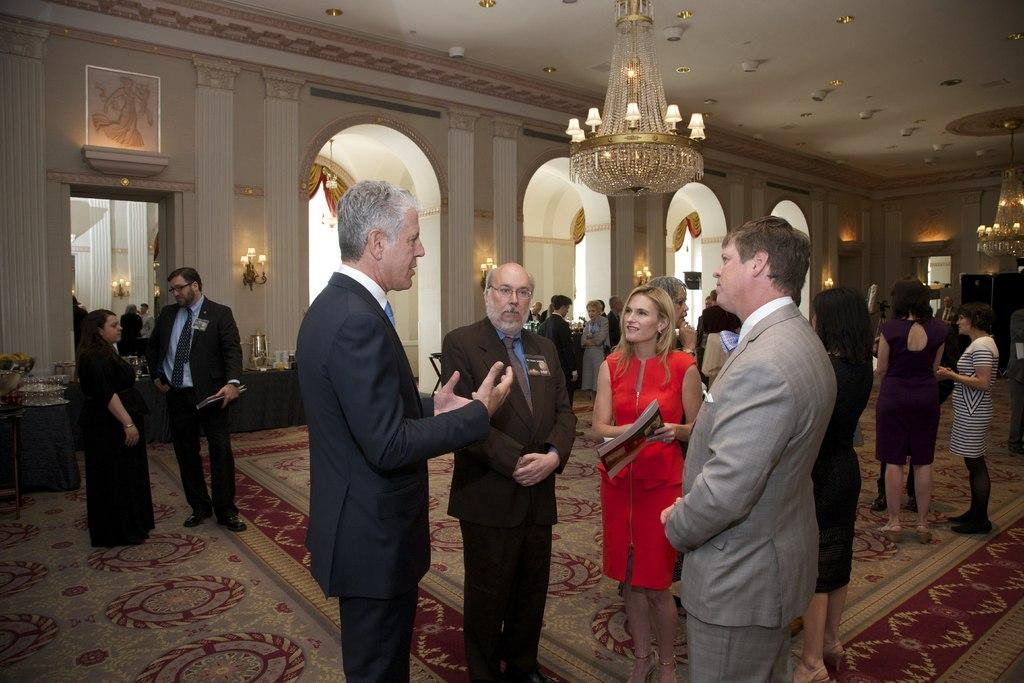What type of clothing can be seen in the image? There are many men's suits in the image. Are there any people present in the image? Yes, there are women standing in the image. What is the floor covering in the image? The floor is covered with a carpet. What type of lighting fixture is hanging from the ceiling? There is a chandelier hanging from the ceiling. What kind of lights can be seen on the wall in the background? There are lights on the wall in the background. How does the frog feel about the comparison between the suits in the image? There is no frog present in the image, and therefore no such comparison or feelings can be observed. 